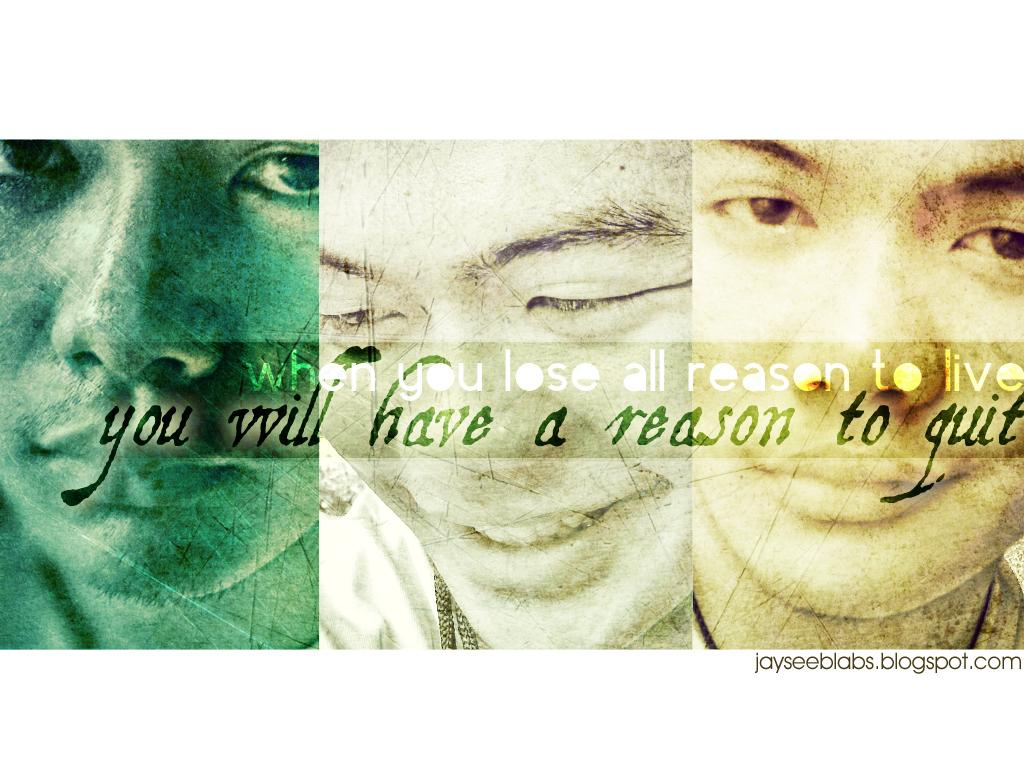What type of image is being described? The image is an edited collage. Can you identify any people in the image? Yes, there is a person in the image. What is the color scheme of the text in the image? The text in the image is black and white. Where is the black color text located in the image? The black color text is in the bottom right corner of the image. What type of bird can be seen flying in the image? There is no bird present in the image; it is an edited collage featuring a person and text. What question is being asked in the image? There is no question present in the image; it contains a person, text, and an edited collage format. 